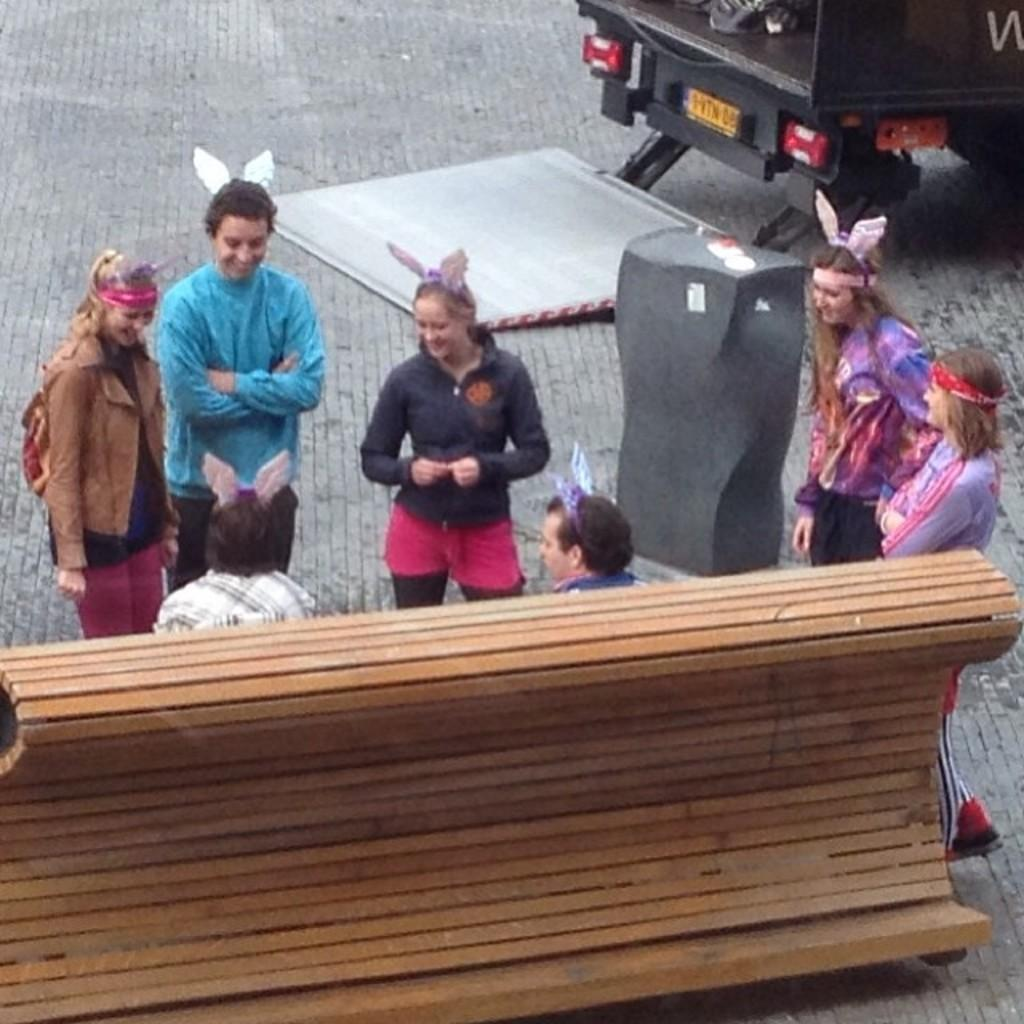How many people are sitting on the wooden bench in the image? There are two people sitting on a wooden bench in the image. What are the people near the sitting people doing? There are people standing near the sitting people, but their actions are not specified in the facts. What can be seen in the background of the image? There is a vehicle visible in the background. Where is the vehicle located in relation to the road? The vehicle is on the road. What type of toys are the people playing with on the wooden bench? There is no mention of toys in the image, so it cannot be determined if people are playing with any toys. 